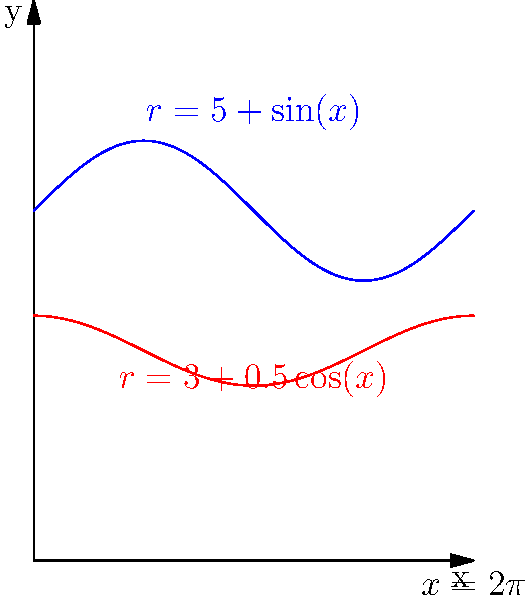A cylindrical artifact inspired by Egyptian canopic jars has a varying cross-section. The radius of the top surface is given by the function $r_1(x)=5+\sin(x)$, and the radius of the bottom surface is given by $r_2(x)=3+0.5\cos(x)$, where $x$ is measured in radians. If the height of the artifact is $10$ cm and the cross-section completes one full revolution ($0 \leq x \leq 2\pi$), find the volume of the artifact. To find the volume of this artifact with varying cross-sections, we need to use the washer method from calculus. Here's the step-by-step solution:

1) The volume formula for a solid with varying cross-sections is:

   $$V = \int_a^b \pi [R(x)^2 - r(x)^2] dx$$

   where $R(x)$ is the outer radius function and $r(x)$ is the inner radius function.

2) In this case, $R(x) = 5+\sin(x)$ and $r(x) = 3+0.5\cos(x)$. The limits of integration are from 0 to $2\pi$.

3) Substituting into the volume formula:

   $$V = \int_0^{2\pi} \pi [(5+\sin(x))^2 - (3+0.5\cos(x))^2] dx$$

4) Expand the squares:

   $$V = \pi \int_0^{2\pi} [25+10\sin(x)+\sin^2(x) - 9-3\cos(x)-0.25\cos^2(x)] dx$$

5) Simplify:

   $$V = \pi \int_0^{2\pi} [16+10\sin(x)-3\cos(x)+\sin^2(x)-0.25\cos^2(x)] dx$$

6) Integrate each term:

   $$V = \pi [16x-10\cos(x)-3\sin(x)+\frac{x}{2}-\frac{\sin(2x)}{4}-\frac{x}{8}+\frac{\sin(2x)}{8}]_0^{2\pi}$$

7) Evaluate the integral:

   $$V = \pi [32\pi-10(1-1)-3(0-0)+\pi-0-\frac{\pi}{4}+0]$$

8) Simplify:

   $$V = \pi [32\pi+\pi-\frac{\pi}{4}] = \pi [\frac{129\pi}{4}]$$

9) Calculate the final result:

   $$V = \frac{129\pi^2}{4} \approx 317.65 \text{ cm}^3$$

Note: The height of 10 cm is not used in this calculation because the volume is already accounted for in the revolution of the cross-section.
Answer: $\frac{129\pi^2}{4} \text{ cm}^3$ 